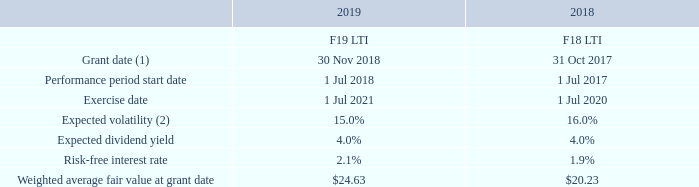Share-based payments expense for the period was $62,028,117 (2018: $57,710,434).
The variables in the table below are used as inputs into the model to determine the fair value of performance rights.
(1) Grant date represents the offer acceptance date.
(2) The expected volatility is based on the historical implied volatility calculated based on the weighted average remaining life of the performance rights adjusted for any expected changes to future volatility due to publicly available information.
What was the share-based payments expense in 2018? $57,710,434. What is the Grant date in 2019? 30 nov 2018. What is the exercise date in 2018? 1 jul 2020. What is the change in expected volatility between 2018 and 2019?
Answer scale should be: percent. 16.0% - 15.0% 
Answer: 1. What is the average risk-free interest rate for 2018 and 2019?
Answer scale should be: percent. (2.1% + 1.9%)/2 
Answer: 2. What is the change in expected dividend yield between 2018 and 2019?
Answer scale should be: percent. 4.0% - 4.0% 
Answer: 0. 